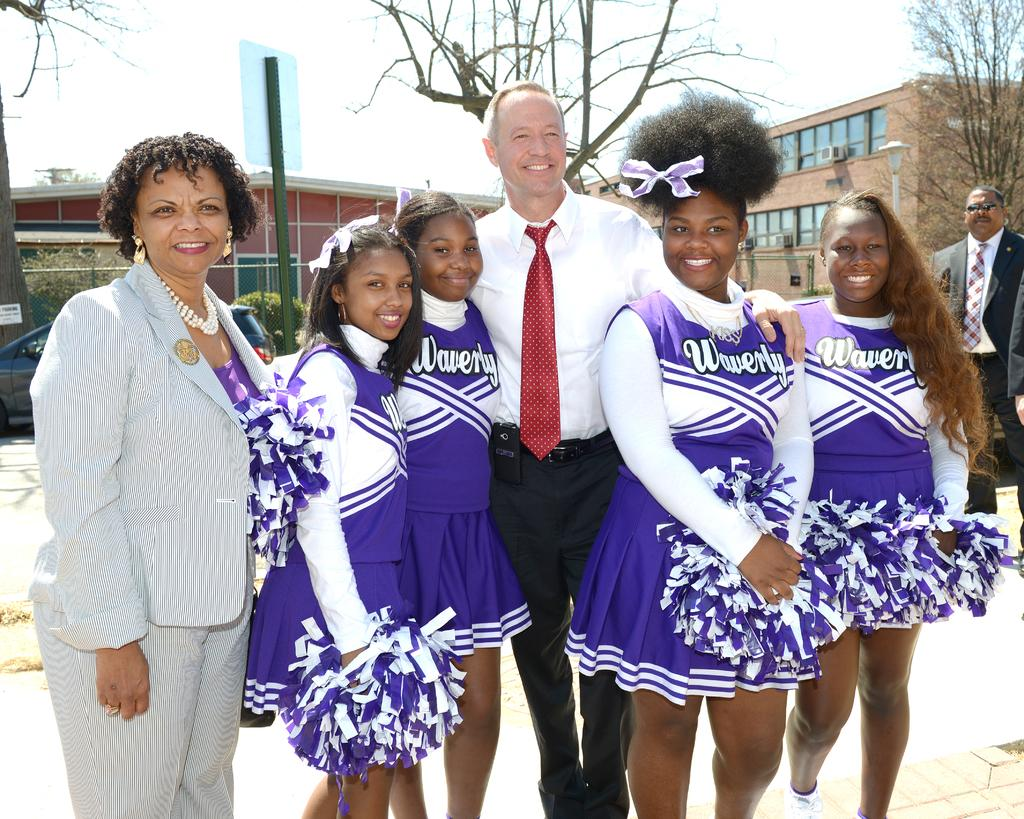<image>
Relay a brief, clear account of the picture shown. Cheerleaders in blue and white with Waverly in white lettering on the front. 